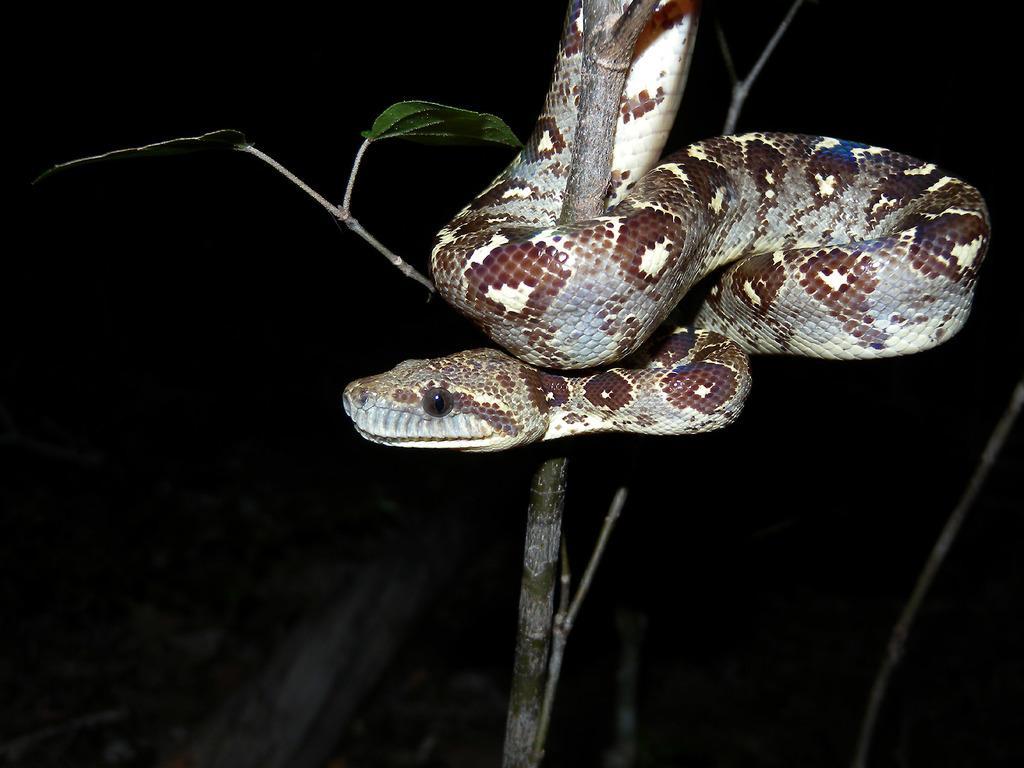Please provide a concise description of this image. In the picture we can see a tree stem to it, we can see a snake and in the background we can see a dark. 